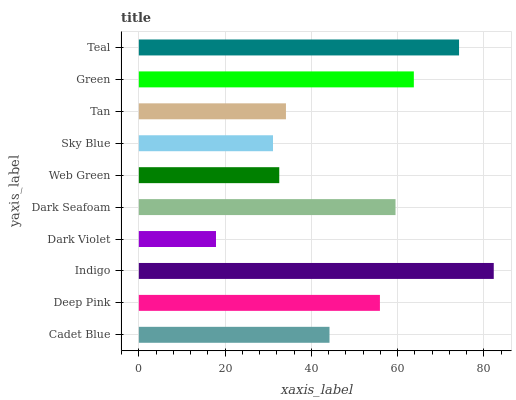Is Dark Violet the minimum?
Answer yes or no. Yes. Is Indigo the maximum?
Answer yes or no. Yes. Is Deep Pink the minimum?
Answer yes or no. No. Is Deep Pink the maximum?
Answer yes or no. No. Is Deep Pink greater than Cadet Blue?
Answer yes or no. Yes. Is Cadet Blue less than Deep Pink?
Answer yes or no. Yes. Is Cadet Blue greater than Deep Pink?
Answer yes or no. No. Is Deep Pink less than Cadet Blue?
Answer yes or no. No. Is Deep Pink the high median?
Answer yes or no. Yes. Is Cadet Blue the low median?
Answer yes or no. Yes. Is Web Green the high median?
Answer yes or no. No. Is Tan the low median?
Answer yes or no. No. 